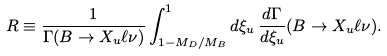<formula> <loc_0><loc_0><loc_500><loc_500>R \equiv \frac { 1 } { \Gamma ( B \to X _ { u } \ell \nu ) } \int _ { 1 - M _ { D } / M _ { B } } ^ { 1 } d \xi _ { u } \, \frac { d \Gamma } { d \xi _ { u } } ( B \to X _ { u } \ell \nu ) .</formula> 